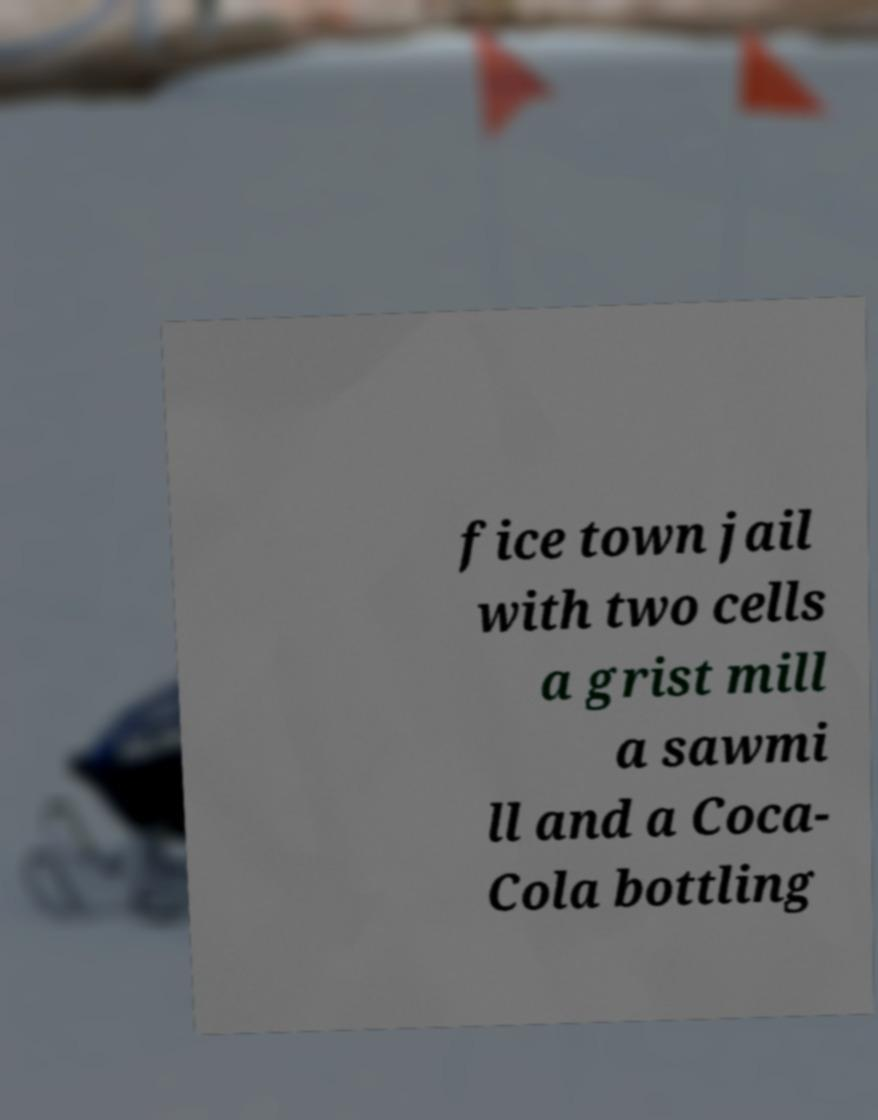Please read and relay the text visible in this image. What does it say? fice town jail with two cells a grist mill a sawmi ll and a Coca- Cola bottling 